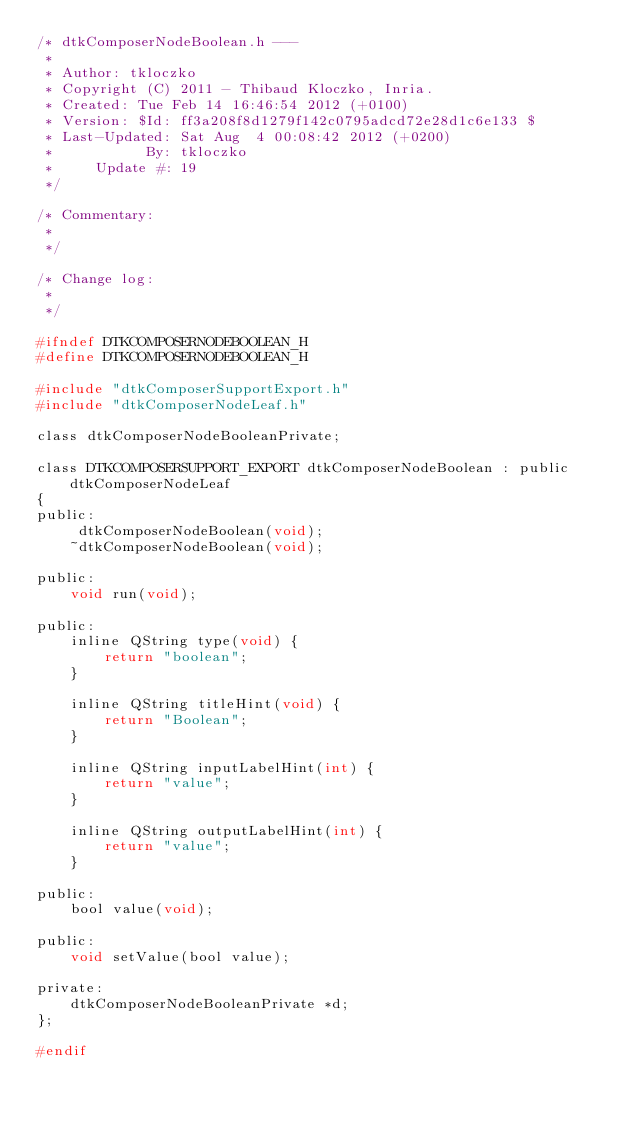<code> <loc_0><loc_0><loc_500><loc_500><_C_>/* dtkComposerNodeBoolean.h --- 
 * 
 * Author: tkloczko
 * Copyright (C) 2011 - Thibaud Kloczko, Inria.
 * Created: Tue Feb 14 16:46:54 2012 (+0100)
 * Version: $Id: ff3a208f8d1279f142c0795adcd72e28d1c6e133 $
 * Last-Updated: Sat Aug  4 00:08:42 2012 (+0200)
 *           By: tkloczko
 *     Update #: 19
 */

/* Commentary: 
 * 
 */

/* Change log:
 * 
 */

#ifndef DTKCOMPOSERNODEBOOLEAN_H
#define DTKCOMPOSERNODEBOOLEAN_H

#include "dtkComposerSupportExport.h"
#include "dtkComposerNodeLeaf.h"

class dtkComposerNodeBooleanPrivate;

class DTKCOMPOSERSUPPORT_EXPORT dtkComposerNodeBoolean : public dtkComposerNodeLeaf
{
public:
     dtkComposerNodeBoolean(void);
    ~dtkComposerNodeBoolean(void);

public:
    void run(void);

public:
    inline QString type(void) {
        return "boolean";
    }

    inline QString titleHint(void) {
        return "Boolean";
    }

    inline QString inputLabelHint(int) {
        return "value";
    }

    inline QString outputLabelHint(int) {
        return "value";
    }

public:
    bool value(void);

public:
    void setValue(bool value);

private:
    dtkComposerNodeBooleanPrivate *d;
};

#endif
</code> 